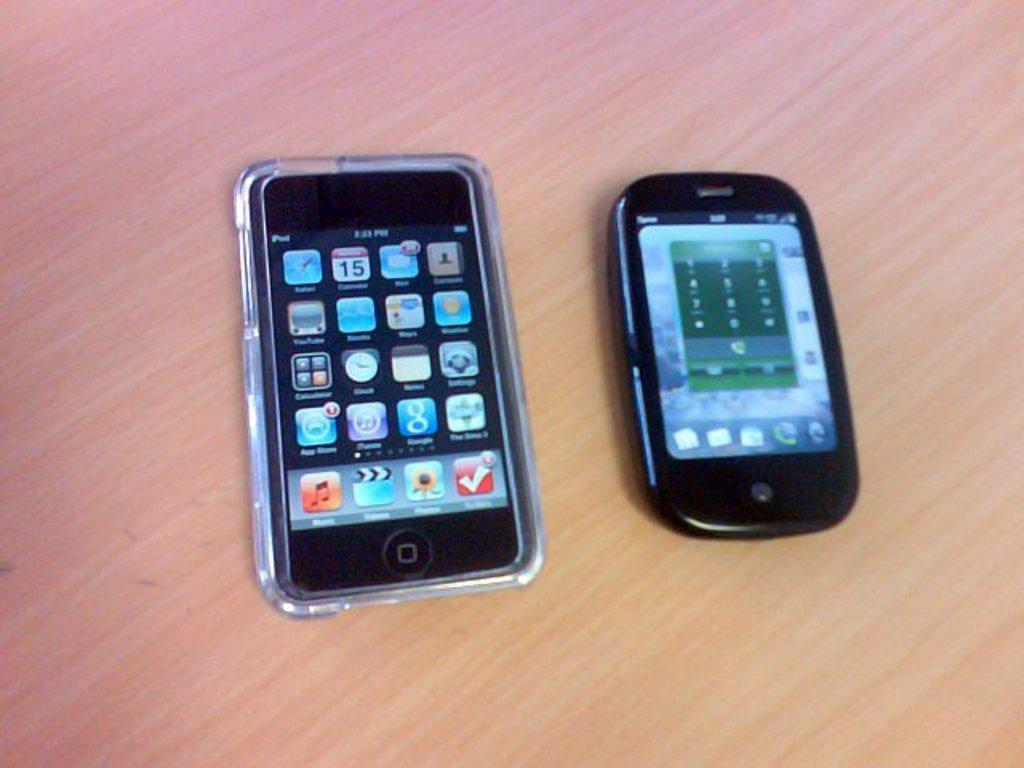<image>
Relay a brief, clear account of the picture shown. an iphone in a clear case with the time on it that says '2:23 pm' 